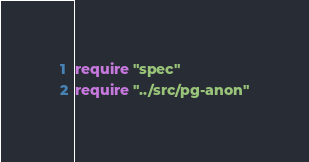<code> <loc_0><loc_0><loc_500><loc_500><_Crystal_>require "spec"
require "../src/pg-anon"
</code> 